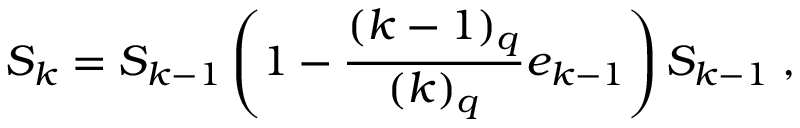Convert formula to latex. <formula><loc_0><loc_0><loc_500><loc_500>S _ { k } = S _ { k - 1 } \left ( 1 - \frac { ( k - 1 ) _ { q } } { ( k ) _ { q } } e _ { k - 1 } \right ) S _ { k - 1 } \, ,</formula> 